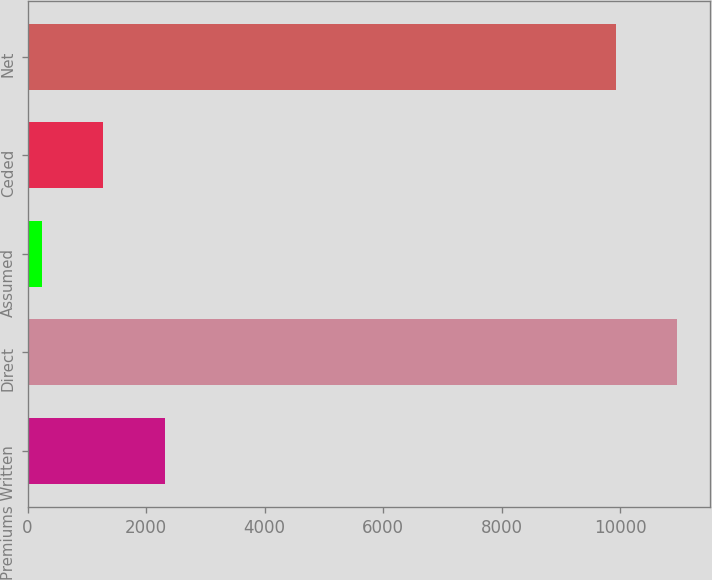<chart> <loc_0><loc_0><loc_500><loc_500><bar_chart><fcel>Premiums Written<fcel>Direct<fcel>Assumed<fcel>Ceded<fcel>Net<nl><fcel>2310.4<fcel>10960.7<fcel>247<fcel>1278.7<fcel>9929<nl></chart> 